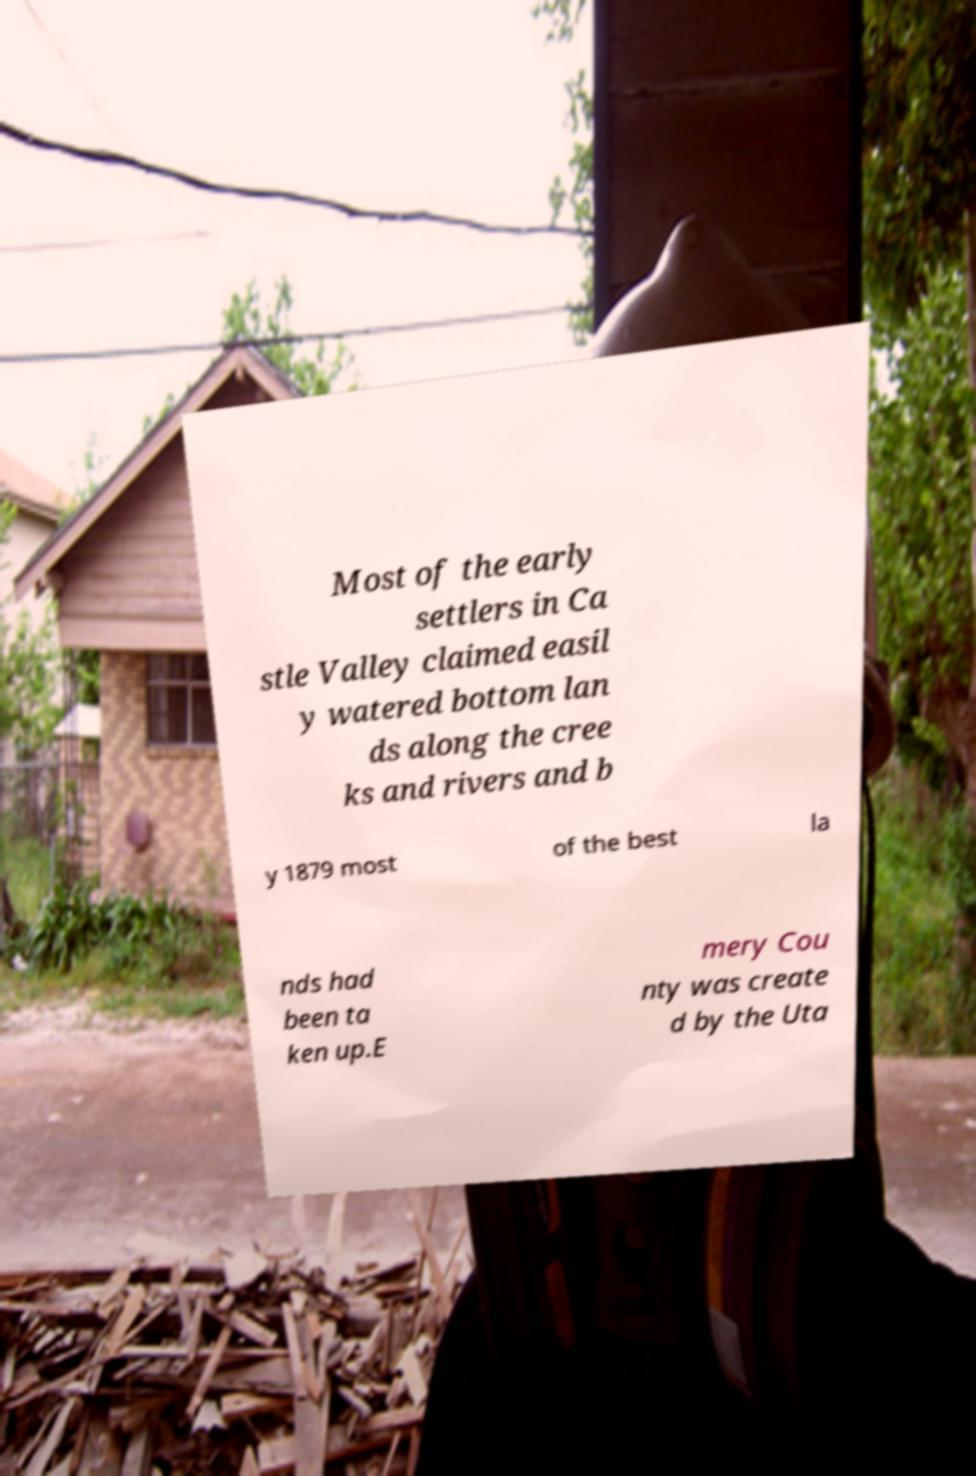What messages or text are displayed in this image? I need them in a readable, typed format. Most of the early settlers in Ca stle Valley claimed easil y watered bottom lan ds along the cree ks and rivers and b y 1879 most of the best la nds had been ta ken up.E mery Cou nty was create d by the Uta 